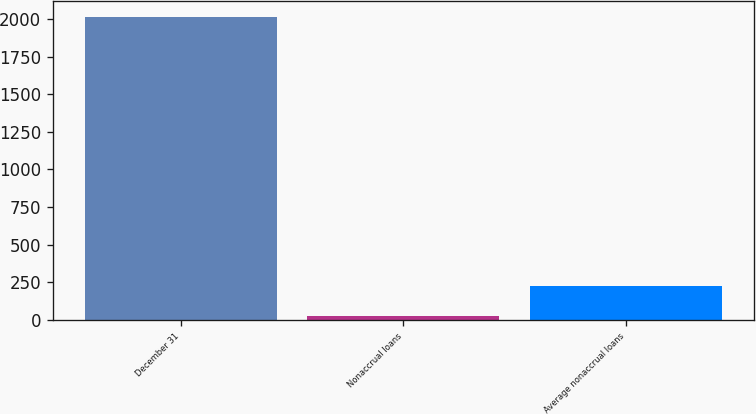Convert chart to OTSL. <chart><loc_0><loc_0><loc_500><loc_500><bar_chart><fcel>December 31<fcel>Nonaccrual loans<fcel>Average nonaccrual loans<nl><fcel>2015<fcel>28<fcel>226.7<nl></chart> 